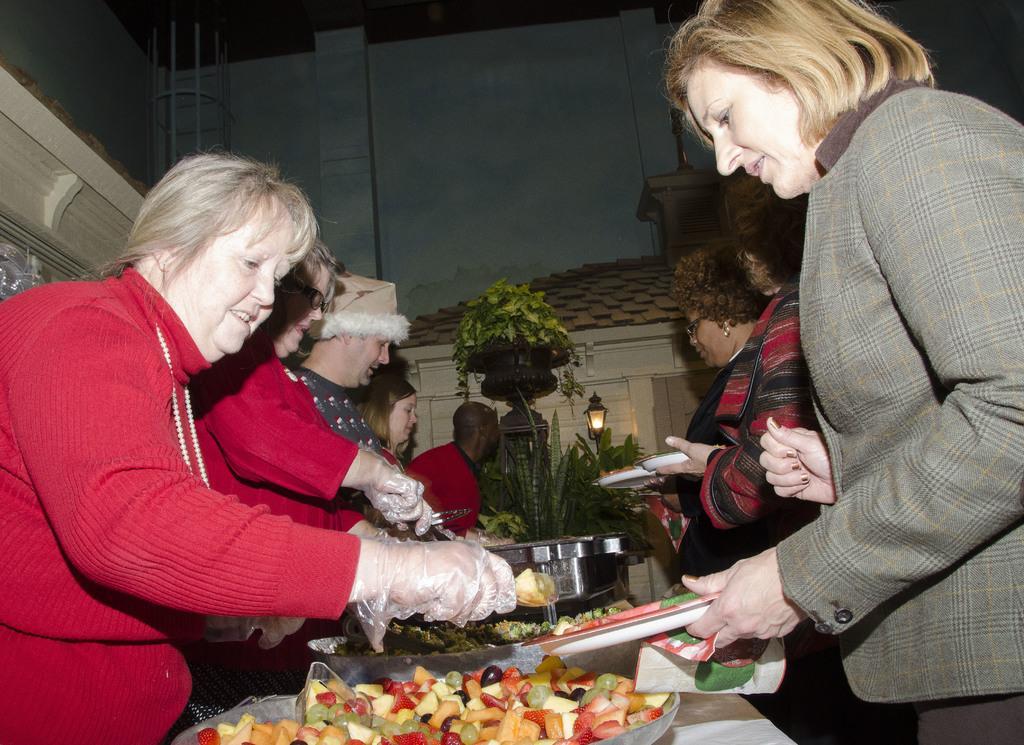In one or two sentences, can you explain what this image depicts? It is a buffet,the chefs are serving the food for the people and different types of food items are kept on the table and behind the table there are some plants,in the background there is a wall and a light is attached to the wall. 